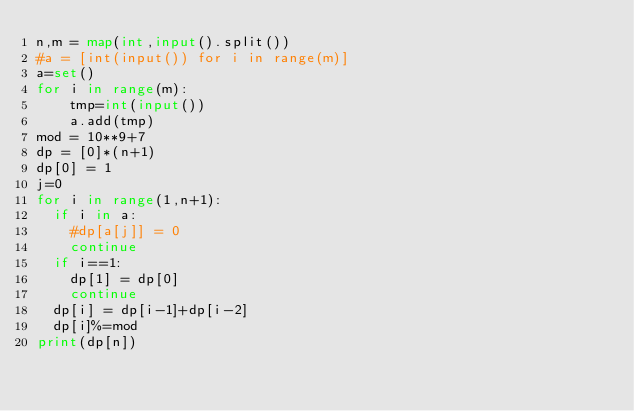<code> <loc_0><loc_0><loc_500><loc_500><_Python_>n,m = map(int,input().split())
#a = [int(input()) for i in range(m)]
a=set()
for i in range(m):
    tmp=int(input())
    a.add(tmp)
mod = 10**9+7
dp = [0]*(n+1)
dp[0] = 1
j=0
for i in range(1,n+1):
  if i in a:
    #dp[a[j]] = 0 
    continue
  if i==1:
    dp[1] = dp[0]
    continue
  dp[i] = dp[i-1]+dp[i-2]
  dp[i]%=mod
print(dp[n])</code> 